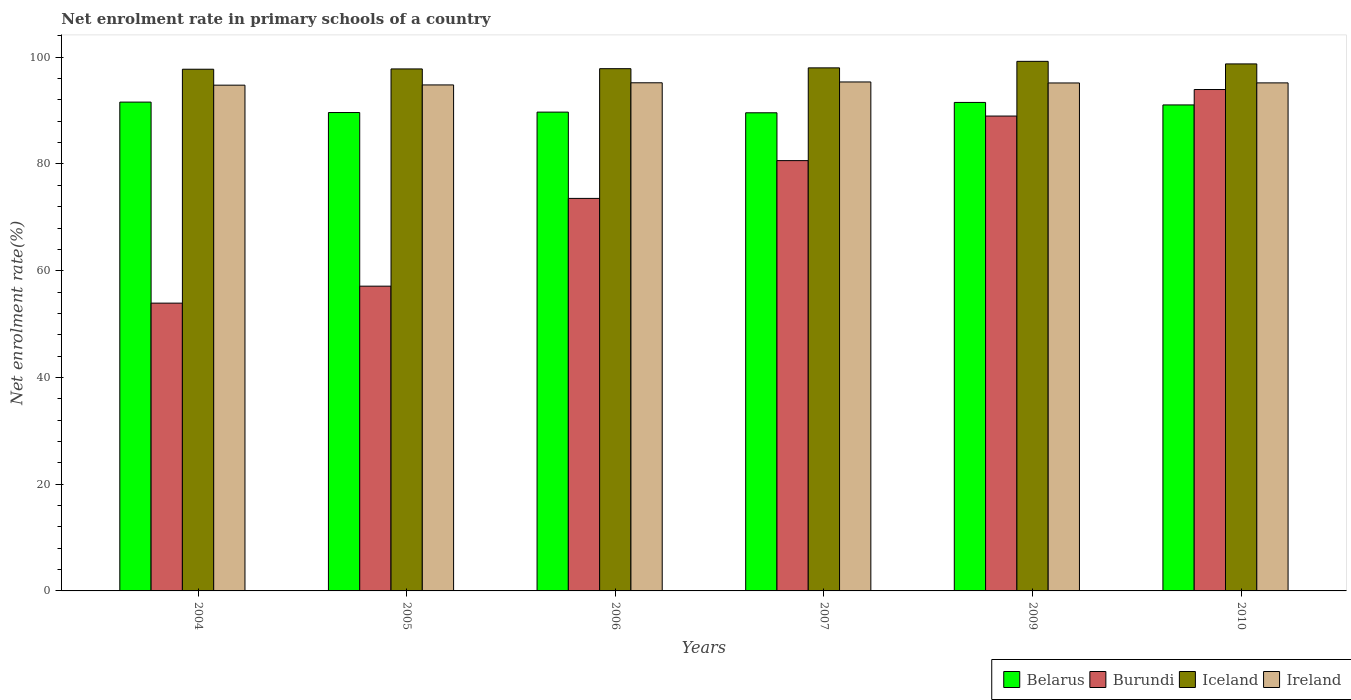How many different coloured bars are there?
Ensure brevity in your answer.  4. How many groups of bars are there?
Offer a terse response. 6. Are the number of bars per tick equal to the number of legend labels?
Offer a terse response. Yes. How many bars are there on the 5th tick from the left?
Your answer should be compact. 4. How many bars are there on the 6th tick from the right?
Your answer should be compact. 4. What is the label of the 2nd group of bars from the left?
Keep it short and to the point. 2005. What is the net enrolment rate in primary schools in Iceland in 2010?
Give a very brief answer. 98.75. Across all years, what is the maximum net enrolment rate in primary schools in Belarus?
Your answer should be compact. 91.59. Across all years, what is the minimum net enrolment rate in primary schools in Belarus?
Provide a succinct answer. 89.59. In which year was the net enrolment rate in primary schools in Ireland minimum?
Your response must be concise. 2004. What is the total net enrolment rate in primary schools in Ireland in the graph?
Make the answer very short. 570.53. What is the difference between the net enrolment rate in primary schools in Iceland in 2004 and that in 2009?
Provide a short and direct response. -1.47. What is the difference between the net enrolment rate in primary schools in Ireland in 2010 and the net enrolment rate in primary schools in Iceland in 2009?
Ensure brevity in your answer.  -4.03. What is the average net enrolment rate in primary schools in Belarus per year?
Offer a terse response. 90.52. In the year 2007, what is the difference between the net enrolment rate in primary schools in Ireland and net enrolment rate in primary schools in Belarus?
Ensure brevity in your answer.  5.78. What is the ratio of the net enrolment rate in primary schools in Burundi in 2004 to that in 2009?
Your answer should be very brief. 0.61. Is the difference between the net enrolment rate in primary schools in Ireland in 2007 and 2009 greater than the difference between the net enrolment rate in primary schools in Belarus in 2007 and 2009?
Give a very brief answer. Yes. What is the difference between the highest and the second highest net enrolment rate in primary schools in Belarus?
Give a very brief answer. 0.06. What is the difference between the highest and the lowest net enrolment rate in primary schools in Ireland?
Offer a terse response. 0.6. Is the sum of the net enrolment rate in primary schools in Ireland in 2004 and 2005 greater than the maximum net enrolment rate in primary schools in Iceland across all years?
Ensure brevity in your answer.  Yes. Is it the case that in every year, the sum of the net enrolment rate in primary schools in Burundi and net enrolment rate in primary schools in Belarus is greater than the sum of net enrolment rate in primary schools in Ireland and net enrolment rate in primary schools in Iceland?
Offer a terse response. No. What does the 4th bar from the left in 2010 represents?
Offer a very short reply. Ireland. What does the 4th bar from the right in 2005 represents?
Make the answer very short. Belarus. Is it the case that in every year, the sum of the net enrolment rate in primary schools in Ireland and net enrolment rate in primary schools in Belarus is greater than the net enrolment rate in primary schools in Iceland?
Provide a short and direct response. Yes. How many bars are there?
Ensure brevity in your answer.  24. Are all the bars in the graph horizontal?
Your answer should be very brief. No. What is the difference between two consecutive major ticks on the Y-axis?
Your answer should be very brief. 20. Does the graph contain grids?
Your answer should be compact. No. Where does the legend appear in the graph?
Provide a short and direct response. Bottom right. How many legend labels are there?
Your answer should be very brief. 4. What is the title of the graph?
Keep it short and to the point. Net enrolment rate in primary schools of a country. Does "Europe(all income levels)" appear as one of the legend labels in the graph?
Offer a very short reply. No. What is the label or title of the Y-axis?
Your response must be concise. Net enrolment rate(%). What is the Net enrolment rate(%) in Belarus in 2004?
Your answer should be very brief. 91.59. What is the Net enrolment rate(%) in Burundi in 2004?
Ensure brevity in your answer.  53.93. What is the Net enrolment rate(%) of Iceland in 2004?
Provide a short and direct response. 97.75. What is the Net enrolment rate(%) in Ireland in 2004?
Keep it short and to the point. 94.77. What is the Net enrolment rate(%) in Belarus in 2005?
Ensure brevity in your answer.  89.64. What is the Net enrolment rate(%) in Burundi in 2005?
Your answer should be compact. 57.1. What is the Net enrolment rate(%) in Iceland in 2005?
Offer a terse response. 97.81. What is the Net enrolment rate(%) of Ireland in 2005?
Make the answer very short. 94.81. What is the Net enrolment rate(%) in Belarus in 2006?
Provide a succinct answer. 89.72. What is the Net enrolment rate(%) of Burundi in 2006?
Offer a terse response. 73.55. What is the Net enrolment rate(%) of Iceland in 2006?
Your answer should be compact. 97.86. What is the Net enrolment rate(%) of Ireland in 2006?
Make the answer very short. 95.21. What is the Net enrolment rate(%) in Belarus in 2007?
Your answer should be compact. 89.59. What is the Net enrolment rate(%) in Burundi in 2007?
Make the answer very short. 80.63. What is the Net enrolment rate(%) in Iceland in 2007?
Give a very brief answer. 98.01. What is the Net enrolment rate(%) in Ireland in 2007?
Make the answer very short. 95.37. What is the Net enrolment rate(%) in Belarus in 2009?
Offer a very short reply. 91.53. What is the Net enrolment rate(%) of Burundi in 2009?
Make the answer very short. 88.98. What is the Net enrolment rate(%) of Iceland in 2009?
Provide a succinct answer. 99.23. What is the Net enrolment rate(%) of Ireland in 2009?
Keep it short and to the point. 95.18. What is the Net enrolment rate(%) in Belarus in 2010?
Give a very brief answer. 91.06. What is the Net enrolment rate(%) in Burundi in 2010?
Give a very brief answer. 93.95. What is the Net enrolment rate(%) of Iceland in 2010?
Offer a terse response. 98.75. What is the Net enrolment rate(%) of Ireland in 2010?
Your answer should be very brief. 95.19. Across all years, what is the maximum Net enrolment rate(%) in Belarus?
Offer a terse response. 91.59. Across all years, what is the maximum Net enrolment rate(%) of Burundi?
Your answer should be very brief. 93.95. Across all years, what is the maximum Net enrolment rate(%) of Iceland?
Your answer should be compact. 99.23. Across all years, what is the maximum Net enrolment rate(%) in Ireland?
Offer a very short reply. 95.37. Across all years, what is the minimum Net enrolment rate(%) in Belarus?
Give a very brief answer. 89.59. Across all years, what is the minimum Net enrolment rate(%) of Burundi?
Provide a short and direct response. 53.93. Across all years, what is the minimum Net enrolment rate(%) in Iceland?
Ensure brevity in your answer.  97.75. Across all years, what is the minimum Net enrolment rate(%) of Ireland?
Your answer should be very brief. 94.77. What is the total Net enrolment rate(%) of Belarus in the graph?
Your answer should be compact. 543.13. What is the total Net enrolment rate(%) in Burundi in the graph?
Your answer should be very brief. 448.14. What is the total Net enrolment rate(%) in Iceland in the graph?
Provide a succinct answer. 589.4. What is the total Net enrolment rate(%) in Ireland in the graph?
Make the answer very short. 570.53. What is the difference between the Net enrolment rate(%) of Belarus in 2004 and that in 2005?
Keep it short and to the point. 1.96. What is the difference between the Net enrolment rate(%) in Burundi in 2004 and that in 2005?
Provide a succinct answer. -3.18. What is the difference between the Net enrolment rate(%) in Iceland in 2004 and that in 2005?
Your answer should be compact. -0.05. What is the difference between the Net enrolment rate(%) of Ireland in 2004 and that in 2005?
Keep it short and to the point. -0.05. What is the difference between the Net enrolment rate(%) of Belarus in 2004 and that in 2006?
Keep it short and to the point. 1.88. What is the difference between the Net enrolment rate(%) in Burundi in 2004 and that in 2006?
Offer a terse response. -19.62. What is the difference between the Net enrolment rate(%) of Iceland in 2004 and that in 2006?
Give a very brief answer. -0.1. What is the difference between the Net enrolment rate(%) of Ireland in 2004 and that in 2006?
Ensure brevity in your answer.  -0.45. What is the difference between the Net enrolment rate(%) in Belarus in 2004 and that in 2007?
Provide a short and direct response. 2. What is the difference between the Net enrolment rate(%) of Burundi in 2004 and that in 2007?
Provide a succinct answer. -26.7. What is the difference between the Net enrolment rate(%) in Iceland in 2004 and that in 2007?
Your answer should be very brief. -0.25. What is the difference between the Net enrolment rate(%) in Ireland in 2004 and that in 2007?
Give a very brief answer. -0.6. What is the difference between the Net enrolment rate(%) in Belarus in 2004 and that in 2009?
Ensure brevity in your answer.  0.06. What is the difference between the Net enrolment rate(%) of Burundi in 2004 and that in 2009?
Ensure brevity in your answer.  -35.05. What is the difference between the Net enrolment rate(%) in Iceland in 2004 and that in 2009?
Your answer should be very brief. -1.47. What is the difference between the Net enrolment rate(%) of Ireland in 2004 and that in 2009?
Give a very brief answer. -0.41. What is the difference between the Net enrolment rate(%) of Belarus in 2004 and that in 2010?
Offer a terse response. 0.53. What is the difference between the Net enrolment rate(%) in Burundi in 2004 and that in 2010?
Offer a very short reply. -40.03. What is the difference between the Net enrolment rate(%) of Iceland in 2004 and that in 2010?
Ensure brevity in your answer.  -1. What is the difference between the Net enrolment rate(%) of Ireland in 2004 and that in 2010?
Your answer should be very brief. -0.43. What is the difference between the Net enrolment rate(%) in Belarus in 2005 and that in 2006?
Your answer should be very brief. -0.08. What is the difference between the Net enrolment rate(%) in Burundi in 2005 and that in 2006?
Offer a terse response. -16.45. What is the difference between the Net enrolment rate(%) of Iceland in 2005 and that in 2006?
Make the answer very short. -0.05. What is the difference between the Net enrolment rate(%) in Ireland in 2005 and that in 2006?
Your response must be concise. -0.4. What is the difference between the Net enrolment rate(%) of Belarus in 2005 and that in 2007?
Your answer should be compact. 0.05. What is the difference between the Net enrolment rate(%) of Burundi in 2005 and that in 2007?
Offer a terse response. -23.53. What is the difference between the Net enrolment rate(%) in Iceland in 2005 and that in 2007?
Provide a short and direct response. -0.2. What is the difference between the Net enrolment rate(%) of Ireland in 2005 and that in 2007?
Keep it short and to the point. -0.56. What is the difference between the Net enrolment rate(%) of Belarus in 2005 and that in 2009?
Make the answer very short. -1.89. What is the difference between the Net enrolment rate(%) of Burundi in 2005 and that in 2009?
Keep it short and to the point. -31.87. What is the difference between the Net enrolment rate(%) of Iceland in 2005 and that in 2009?
Offer a very short reply. -1.42. What is the difference between the Net enrolment rate(%) in Ireland in 2005 and that in 2009?
Your response must be concise. -0.37. What is the difference between the Net enrolment rate(%) in Belarus in 2005 and that in 2010?
Your response must be concise. -1.43. What is the difference between the Net enrolment rate(%) in Burundi in 2005 and that in 2010?
Provide a succinct answer. -36.85. What is the difference between the Net enrolment rate(%) of Iceland in 2005 and that in 2010?
Provide a succinct answer. -0.94. What is the difference between the Net enrolment rate(%) of Ireland in 2005 and that in 2010?
Offer a very short reply. -0.38. What is the difference between the Net enrolment rate(%) of Belarus in 2006 and that in 2007?
Provide a succinct answer. 0.13. What is the difference between the Net enrolment rate(%) of Burundi in 2006 and that in 2007?
Make the answer very short. -7.08. What is the difference between the Net enrolment rate(%) in Iceland in 2006 and that in 2007?
Keep it short and to the point. -0.15. What is the difference between the Net enrolment rate(%) in Ireland in 2006 and that in 2007?
Give a very brief answer. -0.15. What is the difference between the Net enrolment rate(%) in Belarus in 2006 and that in 2009?
Provide a short and direct response. -1.81. What is the difference between the Net enrolment rate(%) of Burundi in 2006 and that in 2009?
Your answer should be very brief. -15.43. What is the difference between the Net enrolment rate(%) in Iceland in 2006 and that in 2009?
Offer a very short reply. -1.37. What is the difference between the Net enrolment rate(%) in Ireland in 2006 and that in 2009?
Make the answer very short. 0.03. What is the difference between the Net enrolment rate(%) of Belarus in 2006 and that in 2010?
Your response must be concise. -1.35. What is the difference between the Net enrolment rate(%) in Burundi in 2006 and that in 2010?
Give a very brief answer. -20.4. What is the difference between the Net enrolment rate(%) in Iceland in 2006 and that in 2010?
Provide a short and direct response. -0.89. What is the difference between the Net enrolment rate(%) of Ireland in 2006 and that in 2010?
Give a very brief answer. 0.02. What is the difference between the Net enrolment rate(%) in Belarus in 2007 and that in 2009?
Provide a succinct answer. -1.94. What is the difference between the Net enrolment rate(%) of Burundi in 2007 and that in 2009?
Your answer should be compact. -8.35. What is the difference between the Net enrolment rate(%) of Iceland in 2007 and that in 2009?
Give a very brief answer. -1.22. What is the difference between the Net enrolment rate(%) in Ireland in 2007 and that in 2009?
Ensure brevity in your answer.  0.19. What is the difference between the Net enrolment rate(%) of Belarus in 2007 and that in 2010?
Provide a succinct answer. -1.47. What is the difference between the Net enrolment rate(%) in Burundi in 2007 and that in 2010?
Your answer should be very brief. -13.32. What is the difference between the Net enrolment rate(%) in Iceland in 2007 and that in 2010?
Provide a succinct answer. -0.74. What is the difference between the Net enrolment rate(%) of Ireland in 2007 and that in 2010?
Offer a terse response. 0.17. What is the difference between the Net enrolment rate(%) in Belarus in 2009 and that in 2010?
Your answer should be very brief. 0.47. What is the difference between the Net enrolment rate(%) in Burundi in 2009 and that in 2010?
Your response must be concise. -4.97. What is the difference between the Net enrolment rate(%) of Iceland in 2009 and that in 2010?
Offer a very short reply. 0.48. What is the difference between the Net enrolment rate(%) in Ireland in 2009 and that in 2010?
Offer a very short reply. -0.02. What is the difference between the Net enrolment rate(%) of Belarus in 2004 and the Net enrolment rate(%) of Burundi in 2005?
Offer a terse response. 34.49. What is the difference between the Net enrolment rate(%) of Belarus in 2004 and the Net enrolment rate(%) of Iceland in 2005?
Offer a very short reply. -6.22. What is the difference between the Net enrolment rate(%) of Belarus in 2004 and the Net enrolment rate(%) of Ireland in 2005?
Ensure brevity in your answer.  -3.22. What is the difference between the Net enrolment rate(%) of Burundi in 2004 and the Net enrolment rate(%) of Iceland in 2005?
Your answer should be compact. -43.88. What is the difference between the Net enrolment rate(%) in Burundi in 2004 and the Net enrolment rate(%) in Ireland in 2005?
Your response must be concise. -40.89. What is the difference between the Net enrolment rate(%) in Iceland in 2004 and the Net enrolment rate(%) in Ireland in 2005?
Provide a succinct answer. 2.94. What is the difference between the Net enrolment rate(%) of Belarus in 2004 and the Net enrolment rate(%) of Burundi in 2006?
Your response must be concise. 18.04. What is the difference between the Net enrolment rate(%) in Belarus in 2004 and the Net enrolment rate(%) in Iceland in 2006?
Keep it short and to the point. -6.26. What is the difference between the Net enrolment rate(%) of Belarus in 2004 and the Net enrolment rate(%) of Ireland in 2006?
Your response must be concise. -3.62. What is the difference between the Net enrolment rate(%) in Burundi in 2004 and the Net enrolment rate(%) in Iceland in 2006?
Offer a terse response. -43.93. What is the difference between the Net enrolment rate(%) in Burundi in 2004 and the Net enrolment rate(%) in Ireland in 2006?
Your answer should be compact. -41.29. What is the difference between the Net enrolment rate(%) of Iceland in 2004 and the Net enrolment rate(%) of Ireland in 2006?
Provide a short and direct response. 2.54. What is the difference between the Net enrolment rate(%) in Belarus in 2004 and the Net enrolment rate(%) in Burundi in 2007?
Make the answer very short. 10.96. What is the difference between the Net enrolment rate(%) of Belarus in 2004 and the Net enrolment rate(%) of Iceland in 2007?
Provide a succinct answer. -6.41. What is the difference between the Net enrolment rate(%) of Belarus in 2004 and the Net enrolment rate(%) of Ireland in 2007?
Offer a terse response. -3.77. What is the difference between the Net enrolment rate(%) in Burundi in 2004 and the Net enrolment rate(%) in Iceland in 2007?
Provide a succinct answer. -44.08. What is the difference between the Net enrolment rate(%) in Burundi in 2004 and the Net enrolment rate(%) in Ireland in 2007?
Your answer should be compact. -41.44. What is the difference between the Net enrolment rate(%) in Iceland in 2004 and the Net enrolment rate(%) in Ireland in 2007?
Offer a terse response. 2.39. What is the difference between the Net enrolment rate(%) in Belarus in 2004 and the Net enrolment rate(%) in Burundi in 2009?
Ensure brevity in your answer.  2.62. What is the difference between the Net enrolment rate(%) of Belarus in 2004 and the Net enrolment rate(%) of Iceland in 2009?
Your response must be concise. -7.63. What is the difference between the Net enrolment rate(%) of Belarus in 2004 and the Net enrolment rate(%) of Ireland in 2009?
Keep it short and to the point. -3.59. What is the difference between the Net enrolment rate(%) of Burundi in 2004 and the Net enrolment rate(%) of Iceland in 2009?
Offer a terse response. -45.3. What is the difference between the Net enrolment rate(%) of Burundi in 2004 and the Net enrolment rate(%) of Ireland in 2009?
Make the answer very short. -41.25. What is the difference between the Net enrolment rate(%) of Iceland in 2004 and the Net enrolment rate(%) of Ireland in 2009?
Your response must be concise. 2.58. What is the difference between the Net enrolment rate(%) in Belarus in 2004 and the Net enrolment rate(%) in Burundi in 2010?
Provide a short and direct response. -2.36. What is the difference between the Net enrolment rate(%) of Belarus in 2004 and the Net enrolment rate(%) of Iceland in 2010?
Keep it short and to the point. -7.16. What is the difference between the Net enrolment rate(%) in Belarus in 2004 and the Net enrolment rate(%) in Ireland in 2010?
Your answer should be very brief. -3.6. What is the difference between the Net enrolment rate(%) of Burundi in 2004 and the Net enrolment rate(%) of Iceland in 2010?
Offer a terse response. -44.82. What is the difference between the Net enrolment rate(%) of Burundi in 2004 and the Net enrolment rate(%) of Ireland in 2010?
Keep it short and to the point. -41.27. What is the difference between the Net enrolment rate(%) of Iceland in 2004 and the Net enrolment rate(%) of Ireland in 2010?
Make the answer very short. 2.56. What is the difference between the Net enrolment rate(%) in Belarus in 2005 and the Net enrolment rate(%) in Burundi in 2006?
Keep it short and to the point. 16.09. What is the difference between the Net enrolment rate(%) of Belarus in 2005 and the Net enrolment rate(%) of Iceland in 2006?
Provide a short and direct response. -8.22. What is the difference between the Net enrolment rate(%) of Belarus in 2005 and the Net enrolment rate(%) of Ireland in 2006?
Your response must be concise. -5.58. What is the difference between the Net enrolment rate(%) in Burundi in 2005 and the Net enrolment rate(%) in Iceland in 2006?
Keep it short and to the point. -40.75. What is the difference between the Net enrolment rate(%) in Burundi in 2005 and the Net enrolment rate(%) in Ireland in 2006?
Your answer should be compact. -38.11. What is the difference between the Net enrolment rate(%) of Iceland in 2005 and the Net enrolment rate(%) of Ireland in 2006?
Your answer should be very brief. 2.6. What is the difference between the Net enrolment rate(%) of Belarus in 2005 and the Net enrolment rate(%) of Burundi in 2007?
Your answer should be very brief. 9.01. What is the difference between the Net enrolment rate(%) in Belarus in 2005 and the Net enrolment rate(%) in Iceland in 2007?
Your answer should be very brief. -8.37. What is the difference between the Net enrolment rate(%) in Belarus in 2005 and the Net enrolment rate(%) in Ireland in 2007?
Your answer should be very brief. -5.73. What is the difference between the Net enrolment rate(%) in Burundi in 2005 and the Net enrolment rate(%) in Iceland in 2007?
Provide a succinct answer. -40.9. What is the difference between the Net enrolment rate(%) in Burundi in 2005 and the Net enrolment rate(%) in Ireland in 2007?
Offer a terse response. -38.26. What is the difference between the Net enrolment rate(%) in Iceland in 2005 and the Net enrolment rate(%) in Ireland in 2007?
Your answer should be compact. 2.44. What is the difference between the Net enrolment rate(%) of Belarus in 2005 and the Net enrolment rate(%) of Burundi in 2009?
Provide a succinct answer. 0.66. What is the difference between the Net enrolment rate(%) in Belarus in 2005 and the Net enrolment rate(%) in Iceland in 2009?
Your response must be concise. -9.59. What is the difference between the Net enrolment rate(%) in Belarus in 2005 and the Net enrolment rate(%) in Ireland in 2009?
Offer a very short reply. -5.54. What is the difference between the Net enrolment rate(%) of Burundi in 2005 and the Net enrolment rate(%) of Iceland in 2009?
Your response must be concise. -42.13. What is the difference between the Net enrolment rate(%) of Burundi in 2005 and the Net enrolment rate(%) of Ireland in 2009?
Ensure brevity in your answer.  -38.08. What is the difference between the Net enrolment rate(%) of Iceland in 2005 and the Net enrolment rate(%) of Ireland in 2009?
Provide a short and direct response. 2.63. What is the difference between the Net enrolment rate(%) of Belarus in 2005 and the Net enrolment rate(%) of Burundi in 2010?
Provide a succinct answer. -4.31. What is the difference between the Net enrolment rate(%) of Belarus in 2005 and the Net enrolment rate(%) of Iceland in 2010?
Offer a very short reply. -9.11. What is the difference between the Net enrolment rate(%) in Belarus in 2005 and the Net enrolment rate(%) in Ireland in 2010?
Your answer should be very brief. -5.56. What is the difference between the Net enrolment rate(%) of Burundi in 2005 and the Net enrolment rate(%) of Iceland in 2010?
Give a very brief answer. -41.65. What is the difference between the Net enrolment rate(%) of Burundi in 2005 and the Net enrolment rate(%) of Ireland in 2010?
Make the answer very short. -38.09. What is the difference between the Net enrolment rate(%) in Iceland in 2005 and the Net enrolment rate(%) in Ireland in 2010?
Give a very brief answer. 2.61. What is the difference between the Net enrolment rate(%) in Belarus in 2006 and the Net enrolment rate(%) in Burundi in 2007?
Give a very brief answer. 9.09. What is the difference between the Net enrolment rate(%) in Belarus in 2006 and the Net enrolment rate(%) in Iceland in 2007?
Keep it short and to the point. -8.29. What is the difference between the Net enrolment rate(%) in Belarus in 2006 and the Net enrolment rate(%) in Ireland in 2007?
Offer a terse response. -5.65. What is the difference between the Net enrolment rate(%) in Burundi in 2006 and the Net enrolment rate(%) in Iceland in 2007?
Your answer should be compact. -24.46. What is the difference between the Net enrolment rate(%) in Burundi in 2006 and the Net enrolment rate(%) in Ireland in 2007?
Make the answer very short. -21.82. What is the difference between the Net enrolment rate(%) in Iceland in 2006 and the Net enrolment rate(%) in Ireland in 2007?
Ensure brevity in your answer.  2.49. What is the difference between the Net enrolment rate(%) in Belarus in 2006 and the Net enrolment rate(%) in Burundi in 2009?
Give a very brief answer. 0.74. What is the difference between the Net enrolment rate(%) of Belarus in 2006 and the Net enrolment rate(%) of Iceland in 2009?
Give a very brief answer. -9.51. What is the difference between the Net enrolment rate(%) in Belarus in 2006 and the Net enrolment rate(%) in Ireland in 2009?
Your answer should be very brief. -5.46. What is the difference between the Net enrolment rate(%) of Burundi in 2006 and the Net enrolment rate(%) of Iceland in 2009?
Provide a succinct answer. -25.68. What is the difference between the Net enrolment rate(%) of Burundi in 2006 and the Net enrolment rate(%) of Ireland in 2009?
Make the answer very short. -21.63. What is the difference between the Net enrolment rate(%) in Iceland in 2006 and the Net enrolment rate(%) in Ireland in 2009?
Provide a short and direct response. 2.68. What is the difference between the Net enrolment rate(%) of Belarus in 2006 and the Net enrolment rate(%) of Burundi in 2010?
Keep it short and to the point. -4.23. What is the difference between the Net enrolment rate(%) of Belarus in 2006 and the Net enrolment rate(%) of Iceland in 2010?
Provide a short and direct response. -9.03. What is the difference between the Net enrolment rate(%) in Belarus in 2006 and the Net enrolment rate(%) in Ireland in 2010?
Ensure brevity in your answer.  -5.48. What is the difference between the Net enrolment rate(%) in Burundi in 2006 and the Net enrolment rate(%) in Iceland in 2010?
Your answer should be compact. -25.2. What is the difference between the Net enrolment rate(%) of Burundi in 2006 and the Net enrolment rate(%) of Ireland in 2010?
Offer a very short reply. -21.64. What is the difference between the Net enrolment rate(%) in Iceland in 2006 and the Net enrolment rate(%) in Ireland in 2010?
Your answer should be compact. 2.66. What is the difference between the Net enrolment rate(%) of Belarus in 2007 and the Net enrolment rate(%) of Burundi in 2009?
Make the answer very short. 0.61. What is the difference between the Net enrolment rate(%) of Belarus in 2007 and the Net enrolment rate(%) of Iceland in 2009?
Offer a very short reply. -9.64. What is the difference between the Net enrolment rate(%) in Belarus in 2007 and the Net enrolment rate(%) in Ireland in 2009?
Give a very brief answer. -5.59. What is the difference between the Net enrolment rate(%) in Burundi in 2007 and the Net enrolment rate(%) in Iceland in 2009?
Your answer should be compact. -18.6. What is the difference between the Net enrolment rate(%) in Burundi in 2007 and the Net enrolment rate(%) in Ireland in 2009?
Keep it short and to the point. -14.55. What is the difference between the Net enrolment rate(%) in Iceland in 2007 and the Net enrolment rate(%) in Ireland in 2009?
Your response must be concise. 2.83. What is the difference between the Net enrolment rate(%) of Belarus in 2007 and the Net enrolment rate(%) of Burundi in 2010?
Offer a terse response. -4.36. What is the difference between the Net enrolment rate(%) in Belarus in 2007 and the Net enrolment rate(%) in Iceland in 2010?
Offer a very short reply. -9.16. What is the difference between the Net enrolment rate(%) of Belarus in 2007 and the Net enrolment rate(%) of Ireland in 2010?
Make the answer very short. -5.6. What is the difference between the Net enrolment rate(%) in Burundi in 2007 and the Net enrolment rate(%) in Iceland in 2010?
Provide a short and direct response. -18.12. What is the difference between the Net enrolment rate(%) of Burundi in 2007 and the Net enrolment rate(%) of Ireland in 2010?
Give a very brief answer. -14.57. What is the difference between the Net enrolment rate(%) in Iceland in 2007 and the Net enrolment rate(%) in Ireland in 2010?
Make the answer very short. 2.81. What is the difference between the Net enrolment rate(%) of Belarus in 2009 and the Net enrolment rate(%) of Burundi in 2010?
Make the answer very short. -2.42. What is the difference between the Net enrolment rate(%) of Belarus in 2009 and the Net enrolment rate(%) of Iceland in 2010?
Offer a very short reply. -7.22. What is the difference between the Net enrolment rate(%) in Belarus in 2009 and the Net enrolment rate(%) in Ireland in 2010?
Provide a short and direct response. -3.66. What is the difference between the Net enrolment rate(%) in Burundi in 2009 and the Net enrolment rate(%) in Iceland in 2010?
Make the answer very short. -9.77. What is the difference between the Net enrolment rate(%) of Burundi in 2009 and the Net enrolment rate(%) of Ireland in 2010?
Provide a succinct answer. -6.22. What is the difference between the Net enrolment rate(%) in Iceland in 2009 and the Net enrolment rate(%) in Ireland in 2010?
Ensure brevity in your answer.  4.03. What is the average Net enrolment rate(%) of Belarus per year?
Keep it short and to the point. 90.52. What is the average Net enrolment rate(%) of Burundi per year?
Your response must be concise. 74.69. What is the average Net enrolment rate(%) of Iceland per year?
Your answer should be compact. 98.23. What is the average Net enrolment rate(%) in Ireland per year?
Offer a terse response. 95.09. In the year 2004, what is the difference between the Net enrolment rate(%) in Belarus and Net enrolment rate(%) in Burundi?
Give a very brief answer. 37.67. In the year 2004, what is the difference between the Net enrolment rate(%) of Belarus and Net enrolment rate(%) of Iceland?
Ensure brevity in your answer.  -6.16. In the year 2004, what is the difference between the Net enrolment rate(%) of Belarus and Net enrolment rate(%) of Ireland?
Give a very brief answer. -3.17. In the year 2004, what is the difference between the Net enrolment rate(%) in Burundi and Net enrolment rate(%) in Iceland?
Offer a terse response. -43.83. In the year 2004, what is the difference between the Net enrolment rate(%) in Burundi and Net enrolment rate(%) in Ireland?
Ensure brevity in your answer.  -40.84. In the year 2004, what is the difference between the Net enrolment rate(%) of Iceland and Net enrolment rate(%) of Ireland?
Provide a short and direct response. 2.99. In the year 2005, what is the difference between the Net enrolment rate(%) of Belarus and Net enrolment rate(%) of Burundi?
Offer a terse response. 32.53. In the year 2005, what is the difference between the Net enrolment rate(%) in Belarus and Net enrolment rate(%) in Iceland?
Offer a very short reply. -8.17. In the year 2005, what is the difference between the Net enrolment rate(%) in Belarus and Net enrolment rate(%) in Ireland?
Offer a terse response. -5.17. In the year 2005, what is the difference between the Net enrolment rate(%) in Burundi and Net enrolment rate(%) in Iceland?
Ensure brevity in your answer.  -40.71. In the year 2005, what is the difference between the Net enrolment rate(%) in Burundi and Net enrolment rate(%) in Ireland?
Your answer should be compact. -37.71. In the year 2005, what is the difference between the Net enrolment rate(%) in Iceland and Net enrolment rate(%) in Ireland?
Give a very brief answer. 3. In the year 2006, what is the difference between the Net enrolment rate(%) in Belarus and Net enrolment rate(%) in Burundi?
Your answer should be very brief. 16.17. In the year 2006, what is the difference between the Net enrolment rate(%) in Belarus and Net enrolment rate(%) in Iceland?
Provide a succinct answer. -8.14. In the year 2006, what is the difference between the Net enrolment rate(%) of Belarus and Net enrolment rate(%) of Ireland?
Make the answer very short. -5.5. In the year 2006, what is the difference between the Net enrolment rate(%) of Burundi and Net enrolment rate(%) of Iceland?
Your answer should be very brief. -24.31. In the year 2006, what is the difference between the Net enrolment rate(%) of Burundi and Net enrolment rate(%) of Ireland?
Ensure brevity in your answer.  -21.66. In the year 2006, what is the difference between the Net enrolment rate(%) of Iceland and Net enrolment rate(%) of Ireland?
Keep it short and to the point. 2.64. In the year 2007, what is the difference between the Net enrolment rate(%) of Belarus and Net enrolment rate(%) of Burundi?
Provide a short and direct response. 8.96. In the year 2007, what is the difference between the Net enrolment rate(%) of Belarus and Net enrolment rate(%) of Iceland?
Offer a terse response. -8.42. In the year 2007, what is the difference between the Net enrolment rate(%) in Belarus and Net enrolment rate(%) in Ireland?
Keep it short and to the point. -5.78. In the year 2007, what is the difference between the Net enrolment rate(%) of Burundi and Net enrolment rate(%) of Iceland?
Offer a terse response. -17.38. In the year 2007, what is the difference between the Net enrolment rate(%) in Burundi and Net enrolment rate(%) in Ireland?
Provide a succinct answer. -14.74. In the year 2007, what is the difference between the Net enrolment rate(%) of Iceland and Net enrolment rate(%) of Ireland?
Your answer should be compact. 2.64. In the year 2009, what is the difference between the Net enrolment rate(%) in Belarus and Net enrolment rate(%) in Burundi?
Offer a terse response. 2.55. In the year 2009, what is the difference between the Net enrolment rate(%) of Belarus and Net enrolment rate(%) of Iceland?
Offer a very short reply. -7.7. In the year 2009, what is the difference between the Net enrolment rate(%) in Belarus and Net enrolment rate(%) in Ireland?
Provide a succinct answer. -3.65. In the year 2009, what is the difference between the Net enrolment rate(%) of Burundi and Net enrolment rate(%) of Iceland?
Your answer should be very brief. -10.25. In the year 2009, what is the difference between the Net enrolment rate(%) of Burundi and Net enrolment rate(%) of Ireland?
Provide a short and direct response. -6.2. In the year 2009, what is the difference between the Net enrolment rate(%) of Iceland and Net enrolment rate(%) of Ireland?
Offer a very short reply. 4.05. In the year 2010, what is the difference between the Net enrolment rate(%) in Belarus and Net enrolment rate(%) in Burundi?
Your answer should be compact. -2.89. In the year 2010, what is the difference between the Net enrolment rate(%) in Belarus and Net enrolment rate(%) in Iceland?
Offer a terse response. -7.69. In the year 2010, what is the difference between the Net enrolment rate(%) in Belarus and Net enrolment rate(%) in Ireland?
Your answer should be compact. -4.13. In the year 2010, what is the difference between the Net enrolment rate(%) in Burundi and Net enrolment rate(%) in Iceland?
Your answer should be very brief. -4.8. In the year 2010, what is the difference between the Net enrolment rate(%) in Burundi and Net enrolment rate(%) in Ireland?
Make the answer very short. -1.24. In the year 2010, what is the difference between the Net enrolment rate(%) in Iceland and Net enrolment rate(%) in Ireland?
Your response must be concise. 3.56. What is the ratio of the Net enrolment rate(%) of Belarus in 2004 to that in 2005?
Ensure brevity in your answer.  1.02. What is the ratio of the Net enrolment rate(%) of Burundi in 2004 to that in 2005?
Provide a short and direct response. 0.94. What is the ratio of the Net enrolment rate(%) of Iceland in 2004 to that in 2005?
Keep it short and to the point. 1. What is the ratio of the Net enrolment rate(%) of Ireland in 2004 to that in 2005?
Ensure brevity in your answer.  1. What is the ratio of the Net enrolment rate(%) of Belarus in 2004 to that in 2006?
Your answer should be compact. 1.02. What is the ratio of the Net enrolment rate(%) of Burundi in 2004 to that in 2006?
Your answer should be compact. 0.73. What is the ratio of the Net enrolment rate(%) of Ireland in 2004 to that in 2006?
Provide a succinct answer. 1. What is the ratio of the Net enrolment rate(%) in Belarus in 2004 to that in 2007?
Keep it short and to the point. 1.02. What is the ratio of the Net enrolment rate(%) in Burundi in 2004 to that in 2007?
Keep it short and to the point. 0.67. What is the ratio of the Net enrolment rate(%) of Ireland in 2004 to that in 2007?
Provide a succinct answer. 0.99. What is the ratio of the Net enrolment rate(%) of Belarus in 2004 to that in 2009?
Offer a very short reply. 1. What is the ratio of the Net enrolment rate(%) in Burundi in 2004 to that in 2009?
Provide a short and direct response. 0.61. What is the ratio of the Net enrolment rate(%) of Iceland in 2004 to that in 2009?
Your answer should be very brief. 0.99. What is the ratio of the Net enrolment rate(%) in Belarus in 2004 to that in 2010?
Your answer should be compact. 1.01. What is the ratio of the Net enrolment rate(%) in Burundi in 2004 to that in 2010?
Provide a short and direct response. 0.57. What is the ratio of the Net enrolment rate(%) in Belarus in 2005 to that in 2006?
Your response must be concise. 1. What is the ratio of the Net enrolment rate(%) of Burundi in 2005 to that in 2006?
Ensure brevity in your answer.  0.78. What is the ratio of the Net enrolment rate(%) of Belarus in 2005 to that in 2007?
Keep it short and to the point. 1. What is the ratio of the Net enrolment rate(%) in Burundi in 2005 to that in 2007?
Make the answer very short. 0.71. What is the ratio of the Net enrolment rate(%) in Ireland in 2005 to that in 2007?
Offer a terse response. 0.99. What is the ratio of the Net enrolment rate(%) in Belarus in 2005 to that in 2009?
Offer a terse response. 0.98. What is the ratio of the Net enrolment rate(%) in Burundi in 2005 to that in 2009?
Keep it short and to the point. 0.64. What is the ratio of the Net enrolment rate(%) of Iceland in 2005 to that in 2009?
Keep it short and to the point. 0.99. What is the ratio of the Net enrolment rate(%) of Belarus in 2005 to that in 2010?
Offer a very short reply. 0.98. What is the ratio of the Net enrolment rate(%) of Burundi in 2005 to that in 2010?
Provide a short and direct response. 0.61. What is the ratio of the Net enrolment rate(%) of Ireland in 2005 to that in 2010?
Your response must be concise. 1. What is the ratio of the Net enrolment rate(%) of Burundi in 2006 to that in 2007?
Give a very brief answer. 0.91. What is the ratio of the Net enrolment rate(%) in Iceland in 2006 to that in 2007?
Offer a very short reply. 1. What is the ratio of the Net enrolment rate(%) in Belarus in 2006 to that in 2009?
Your response must be concise. 0.98. What is the ratio of the Net enrolment rate(%) of Burundi in 2006 to that in 2009?
Provide a succinct answer. 0.83. What is the ratio of the Net enrolment rate(%) in Iceland in 2006 to that in 2009?
Your response must be concise. 0.99. What is the ratio of the Net enrolment rate(%) in Belarus in 2006 to that in 2010?
Give a very brief answer. 0.99. What is the ratio of the Net enrolment rate(%) of Burundi in 2006 to that in 2010?
Give a very brief answer. 0.78. What is the ratio of the Net enrolment rate(%) of Iceland in 2006 to that in 2010?
Provide a succinct answer. 0.99. What is the ratio of the Net enrolment rate(%) of Belarus in 2007 to that in 2009?
Your response must be concise. 0.98. What is the ratio of the Net enrolment rate(%) of Burundi in 2007 to that in 2009?
Make the answer very short. 0.91. What is the ratio of the Net enrolment rate(%) in Iceland in 2007 to that in 2009?
Offer a very short reply. 0.99. What is the ratio of the Net enrolment rate(%) in Ireland in 2007 to that in 2009?
Offer a terse response. 1. What is the ratio of the Net enrolment rate(%) in Belarus in 2007 to that in 2010?
Make the answer very short. 0.98. What is the ratio of the Net enrolment rate(%) of Burundi in 2007 to that in 2010?
Make the answer very short. 0.86. What is the ratio of the Net enrolment rate(%) of Belarus in 2009 to that in 2010?
Your answer should be compact. 1.01. What is the ratio of the Net enrolment rate(%) in Burundi in 2009 to that in 2010?
Keep it short and to the point. 0.95. What is the ratio of the Net enrolment rate(%) of Iceland in 2009 to that in 2010?
Provide a short and direct response. 1. What is the ratio of the Net enrolment rate(%) in Ireland in 2009 to that in 2010?
Your response must be concise. 1. What is the difference between the highest and the second highest Net enrolment rate(%) in Belarus?
Your answer should be very brief. 0.06. What is the difference between the highest and the second highest Net enrolment rate(%) in Burundi?
Keep it short and to the point. 4.97. What is the difference between the highest and the second highest Net enrolment rate(%) in Iceland?
Offer a very short reply. 0.48. What is the difference between the highest and the second highest Net enrolment rate(%) of Ireland?
Make the answer very short. 0.15. What is the difference between the highest and the lowest Net enrolment rate(%) in Belarus?
Your response must be concise. 2. What is the difference between the highest and the lowest Net enrolment rate(%) in Burundi?
Provide a succinct answer. 40.03. What is the difference between the highest and the lowest Net enrolment rate(%) of Iceland?
Make the answer very short. 1.47. What is the difference between the highest and the lowest Net enrolment rate(%) in Ireland?
Your answer should be compact. 0.6. 